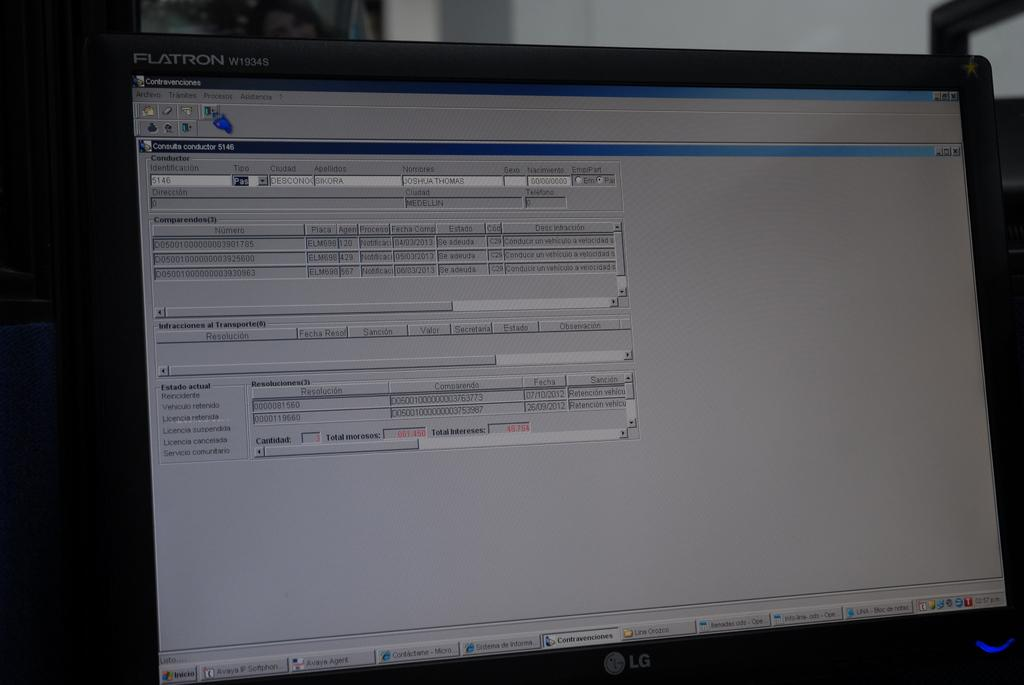What electronic device is present in the image? There is a computer in the image. What can be seen at the top of the image? There is a wall visible at the top of the image. What flavor of rat can be seen crawling on the computer in the image? There is no rat present in the image, and therefore no flavor can be determined. 